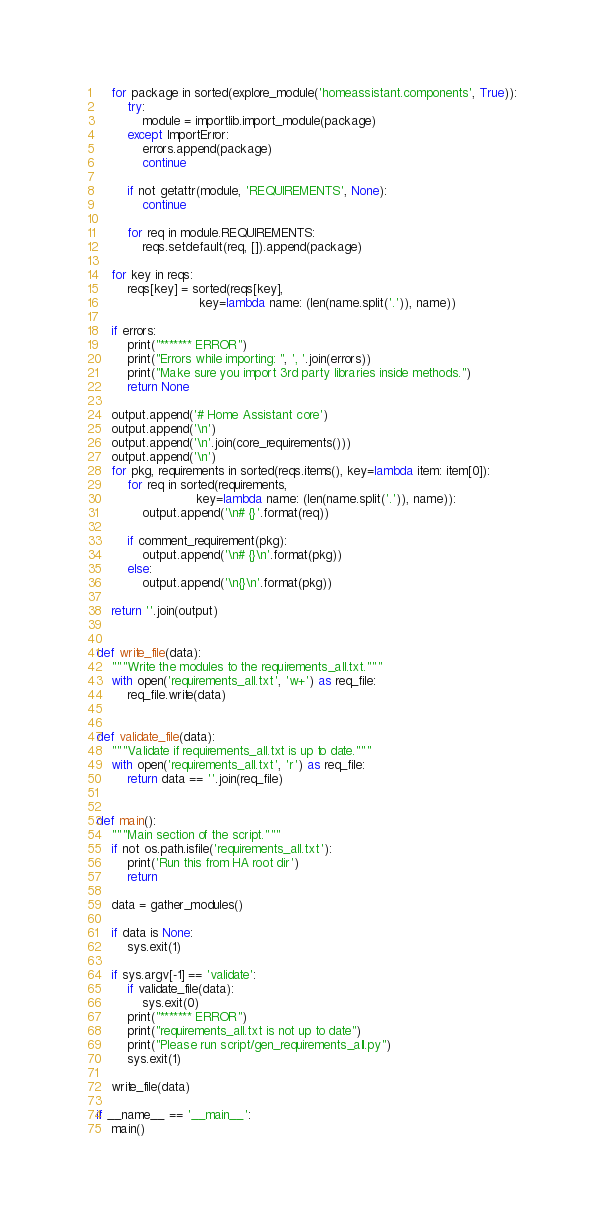Convert code to text. <code><loc_0><loc_0><loc_500><loc_500><_Python_>    for package in sorted(explore_module('homeassistant.components', True)):
        try:
            module = importlib.import_module(package)
        except ImportError:
            errors.append(package)
            continue

        if not getattr(module, 'REQUIREMENTS', None):
            continue

        for req in module.REQUIREMENTS:
            reqs.setdefault(req, []).append(package)

    for key in reqs:
        reqs[key] = sorted(reqs[key],
                           key=lambda name: (len(name.split('.')), name))

    if errors:
        print("******* ERROR")
        print("Errors while importing: ", ', '.join(errors))
        print("Make sure you import 3rd party libraries inside methods.")
        return None

    output.append('# Home Assistant core')
    output.append('\n')
    output.append('\n'.join(core_requirements()))
    output.append('\n')
    for pkg, requirements in sorted(reqs.items(), key=lambda item: item[0]):
        for req in sorted(requirements,
                          key=lambda name: (len(name.split('.')), name)):
            output.append('\n# {}'.format(req))

        if comment_requirement(pkg):
            output.append('\n# {}\n'.format(pkg))
        else:
            output.append('\n{}\n'.format(pkg))

    return ''.join(output)


def write_file(data):
    """Write the modules to the requirements_all.txt."""
    with open('requirements_all.txt', 'w+') as req_file:
        req_file.write(data)


def validate_file(data):
    """Validate if requirements_all.txt is up to date."""
    with open('requirements_all.txt', 'r') as req_file:
        return data == ''.join(req_file)


def main():
    """Main section of the script."""
    if not os.path.isfile('requirements_all.txt'):
        print('Run this from HA root dir')
        return

    data = gather_modules()

    if data is None:
        sys.exit(1)

    if sys.argv[-1] == 'validate':
        if validate_file(data):
            sys.exit(0)
        print("******* ERROR")
        print("requirements_all.txt is not up to date")
        print("Please run script/gen_requirements_all.py")
        sys.exit(1)

    write_file(data)

if __name__ == '__main__':
    main()
</code> 